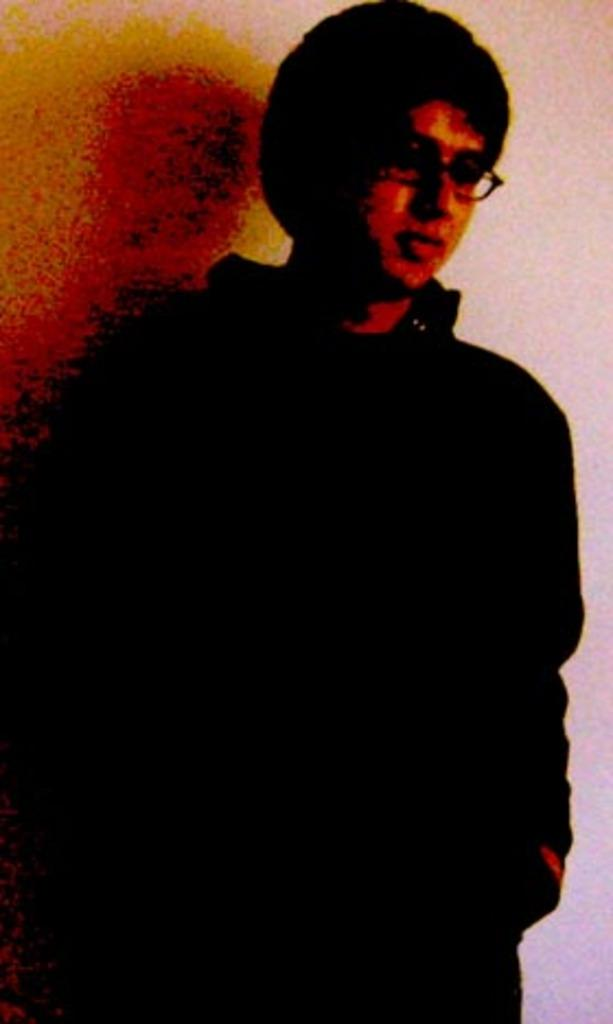Who or what is present in the image? There is a person in the image. What direction is the person looking in? The person is looking to the right. What accessory is the person wearing? The person is wearing spectacles. What type of match is the person holding in the image? There is no match present in the image; the person is wearing spectacles. How much zinc can be seen in the image? There is no zinc present in the image. 